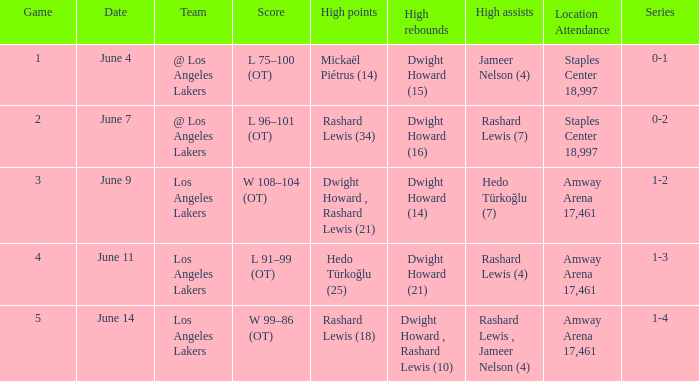Could you parse the entire table? {'header': ['Game', 'Date', 'Team', 'Score', 'High points', 'High rebounds', 'High assists', 'Location Attendance', 'Series'], 'rows': [['1', 'June 4', '@ Los Angeles Lakers', 'L 75–100 (OT)', 'Mickaël Piétrus (14)', 'Dwight Howard (15)', 'Jameer Nelson (4)', 'Staples Center 18,997', '0-1'], ['2', 'June 7', '@ Los Angeles Lakers', 'L 96–101 (OT)', 'Rashard Lewis (34)', 'Dwight Howard (16)', 'Rashard Lewis (7)', 'Staples Center 18,997', '0-2'], ['3', 'June 9', 'Los Angeles Lakers', 'W 108–104 (OT)', 'Dwight Howard , Rashard Lewis (21)', 'Dwight Howard (14)', 'Hedo Türkoğlu (7)', 'Amway Arena 17,461', '1-2'], ['4', 'June 11', 'Los Angeles Lakers', 'L 91–99 (OT)', 'Hedo Türkoğlu (25)', 'Dwight Howard (21)', 'Rashard Lewis (4)', 'Amway Arena 17,461', '1-3'], ['5', 'June 14', 'Los Angeles Lakers', 'W 99–86 (OT)', 'Rashard Lewis (18)', 'Dwight Howard , Rashard Lewis (10)', 'Rashard Lewis , Jameer Nelson (4)', 'Amway Arena 17,461', '1-4']]} What is the series, when the date is "june 7"? 0-2. 